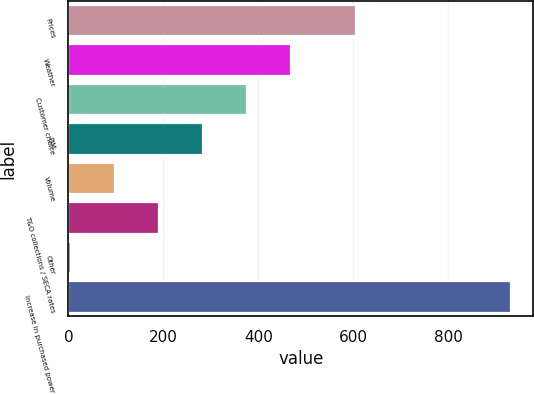Convert chart to OTSL. <chart><loc_0><loc_0><loc_500><loc_500><bar_chart><fcel>Prices<fcel>Weather<fcel>Customer choice<fcel>PJM<fcel>Volume<fcel>T&O collections / SECA rates<fcel>Other<fcel>Increase in purchased power<nl><fcel>606<fcel>469<fcel>376.4<fcel>283.8<fcel>98.6<fcel>191.2<fcel>6<fcel>932<nl></chart> 